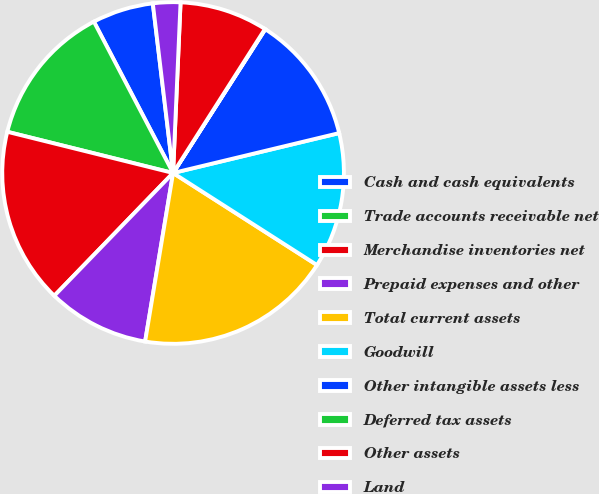Convert chart. <chart><loc_0><loc_0><loc_500><loc_500><pie_chart><fcel>Cash and cash equivalents<fcel>Trade accounts receivable net<fcel>Merchandise inventories net<fcel>Prepaid expenses and other<fcel>Total current assets<fcel>Goodwill<fcel>Other intangible assets less<fcel>Deferred tax assets<fcel>Other assets<fcel>Land<nl><fcel>5.78%<fcel>13.45%<fcel>16.64%<fcel>9.62%<fcel>18.56%<fcel>12.81%<fcel>12.17%<fcel>0.04%<fcel>8.34%<fcel>2.59%<nl></chart> 